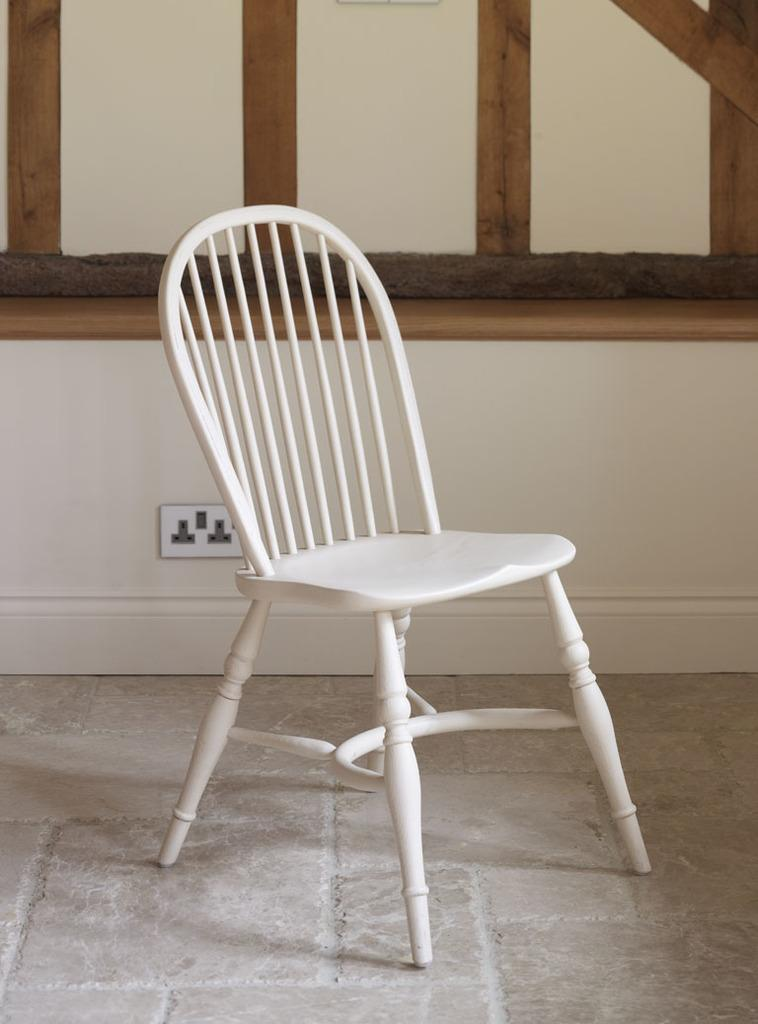What type of furniture is in the image? There is a chair in the image. Where is the chair located? The chair is on the floor. What can be seen in the background of the image? There is a wall in the background of the image. What feature is present on the wall? There is a socket on the wall. What type of bun is on the chair in the image? There is no bun present on the chair or in the image. Can you see a cow in the image? No, there is no cow present in the image. 